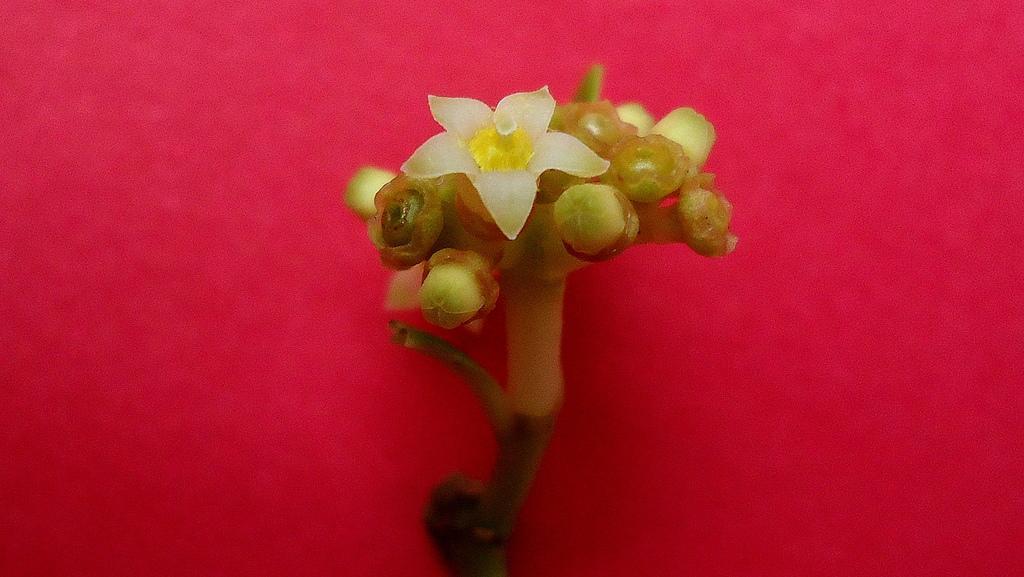Describe this image in one or two sentences. In this image we can see a flower and buds placed on the table. 